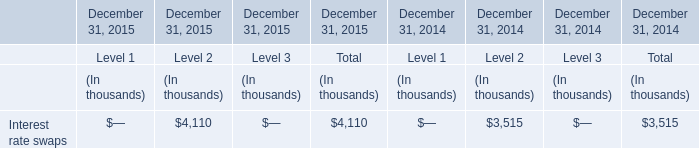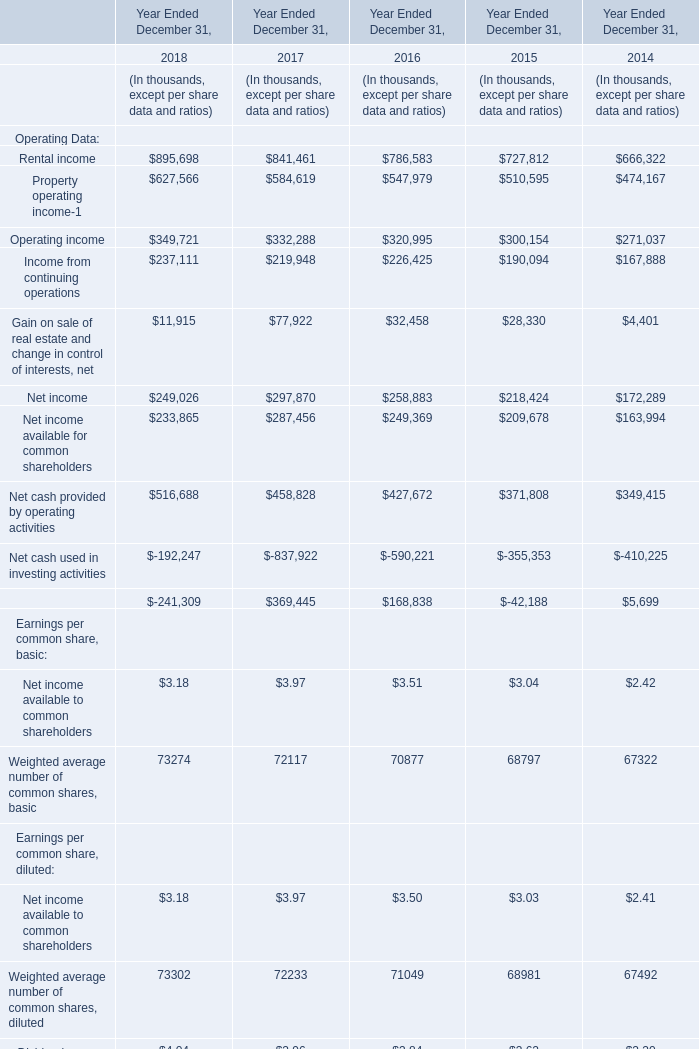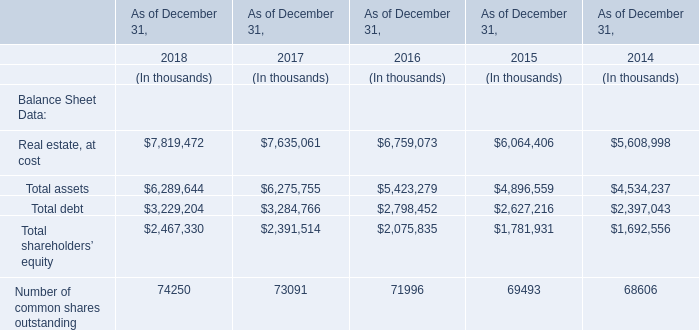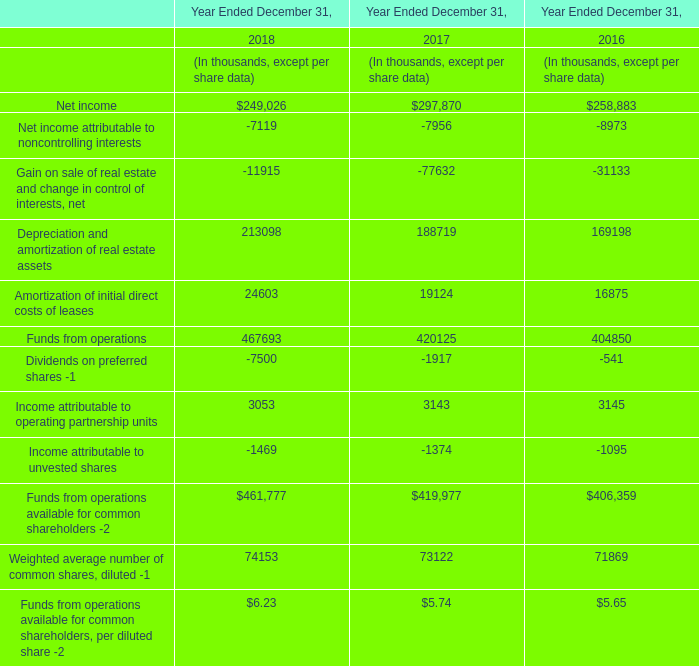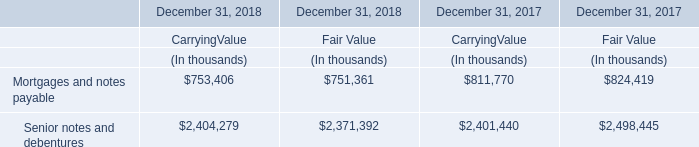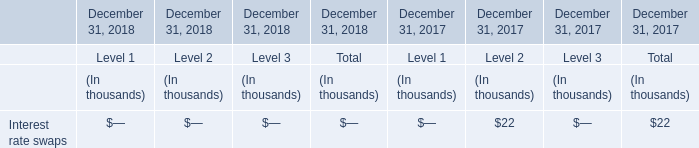What is the growing rate of Total debt in the year with the most Total assets? 
Computations: ((3229204 - 3284766) / 3229204)
Answer: -0.01721. 